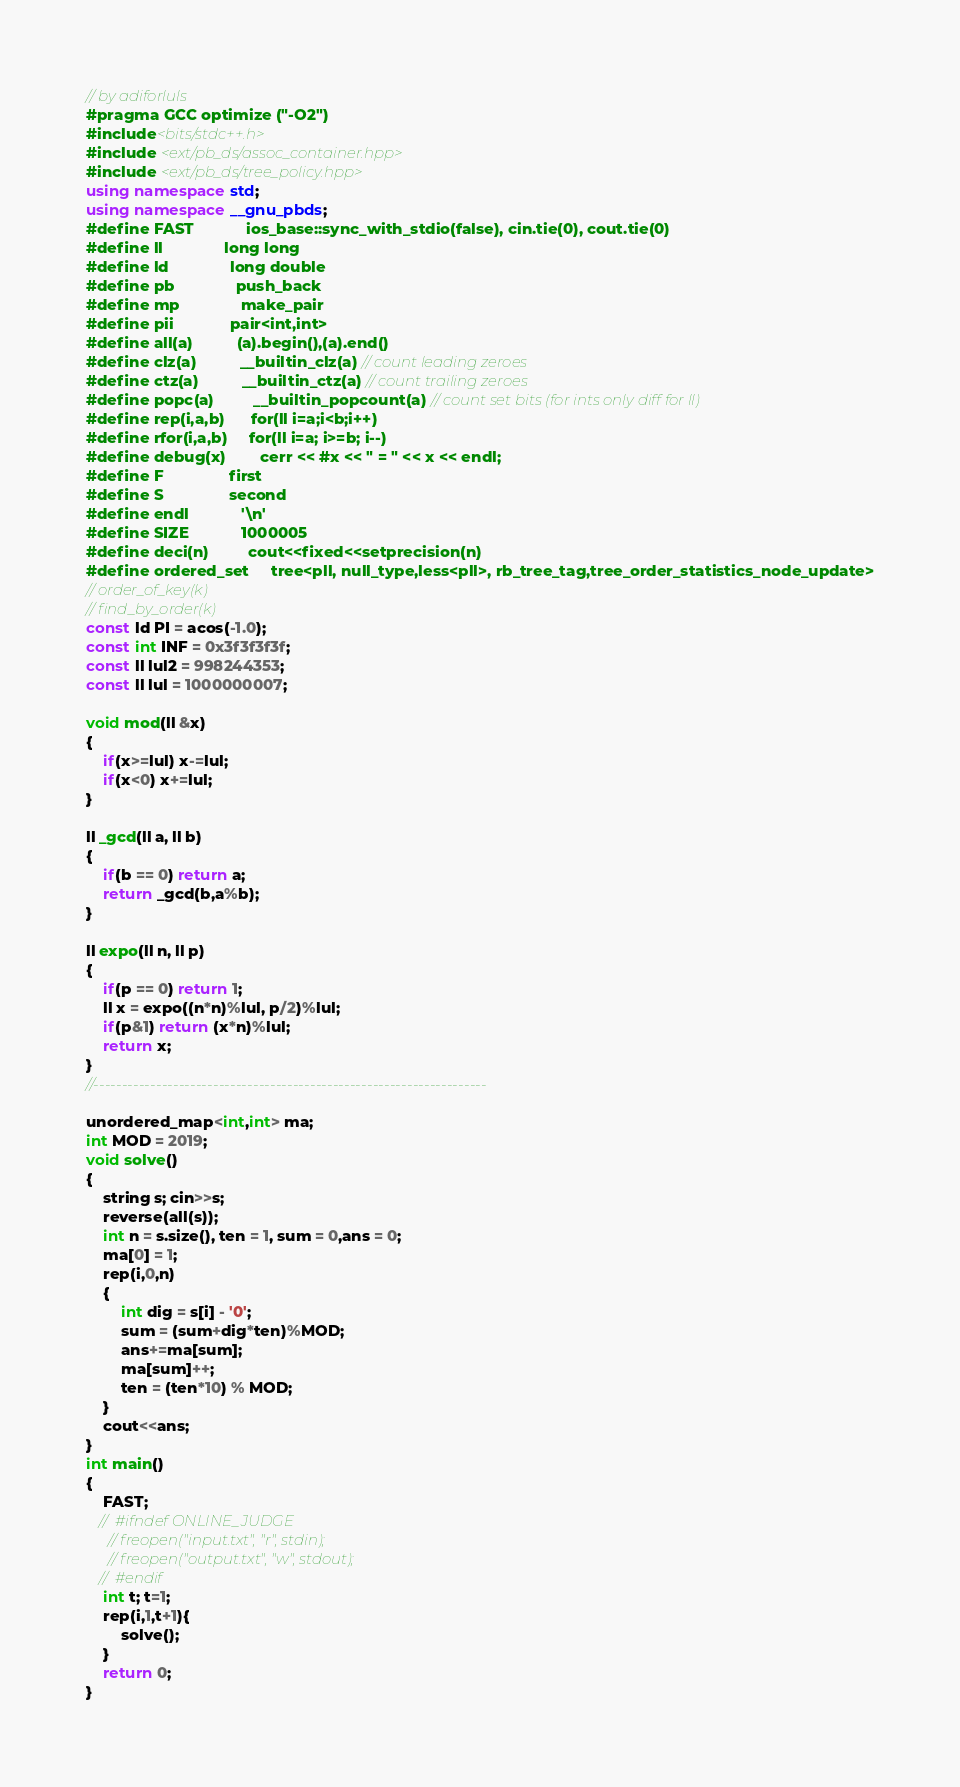Convert code to text. <code><loc_0><loc_0><loc_500><loc_500><_C++_>// by adiforluls
#pragma GCC optimize ("-O2")
#include<bits/stdc++.h>
#include <ext/pb_ds/assoc_container.hpp>
#include <ext/pb_ds/tree_policy.hpp>
using namespace std;
using namespace __gnu_pbds;
#define FAST            ios_base::sync_with_stdio(false), cin.tie(0), cout.tie(0)
#define ll              long long
#define ld              long double
#define pb              push_back
#define mp              make_pair
#define pii             pair<int,int>
#define all(a)          (a).begin(),(a).end()
#define clz(a)          __builtin_clz(a) // count leading zeroes
#define ctz(a)          __builtin_ctz(a) // count trailing zeroes
#define popc(a)         __builtin_popcount(a) // count set bits (for ints only diff for ll)
#define rep(i,a,b)      for(ll i=a;i<b;i++)
#define rfor(i,a,b)     for(ll i=a; i>=b; i--)
#define debug(x)        cerr << #x << " = " << x << endl;
#define F               first
#define S               second
#define endl            '\n'
#define SIZE            1000005
#define deci(n)         cout<<fixed<<setprecision(n)
#define ordered_set     tree<pll, null_type,less<pll>, rb_tree_tag,tree_order_statistics_node_update>
// order_of_key(k)
// find_by_order(k)
const ld PI = acos(-1.0);
const int INF = 0x3f3f3f3f;
const ll lul2 = 998244353;
const ll lul = 1000000007;

void mod(ll &x)
{
    if(x>=lul) x-=lul;
    if(x<0) x+=lul;
}

ll _gcd(ll a, ll b)
{
    if(b == 0) return a;
    return _gcd(b,a%b);
}

ll expo(ll n, ll p)
{
    if(p == 0) return 1;
    ll x = expo((n*n)%lul, p/2)%lul;
    if(p&1) return (x*n)%lul;
    return x;
}
//---------------------------------------------------------------------

unordered_map<int,int> ma;
int MOD = 2019;
void solve()
{
    string s; cin>>s;
    reverse(all(s));
    int n = s.size(), ten = 1, sum = 0,ans = 0;
    ma[0] = 1;
    rep(i,0,n)
    {
        int dig = s[i] - '0';
        sum = (sum+dig*ten)%MOD;
        ans+=ma[sum];
        ma[sum]++;
        ten = (ten*10) % MOD;
    }
    cout<<ans;
}
int main()
{   
    FAST;
   //  #ifndef ONLINE_JUDGE
     // freopen("input.txt", "r", stdin);
     // freopen("output.txt", "w", stdout);
   //  #endif
    int t; t=1;
    rep(i,1,t+1){
        solve();
    }
    return 0;
}</code> 